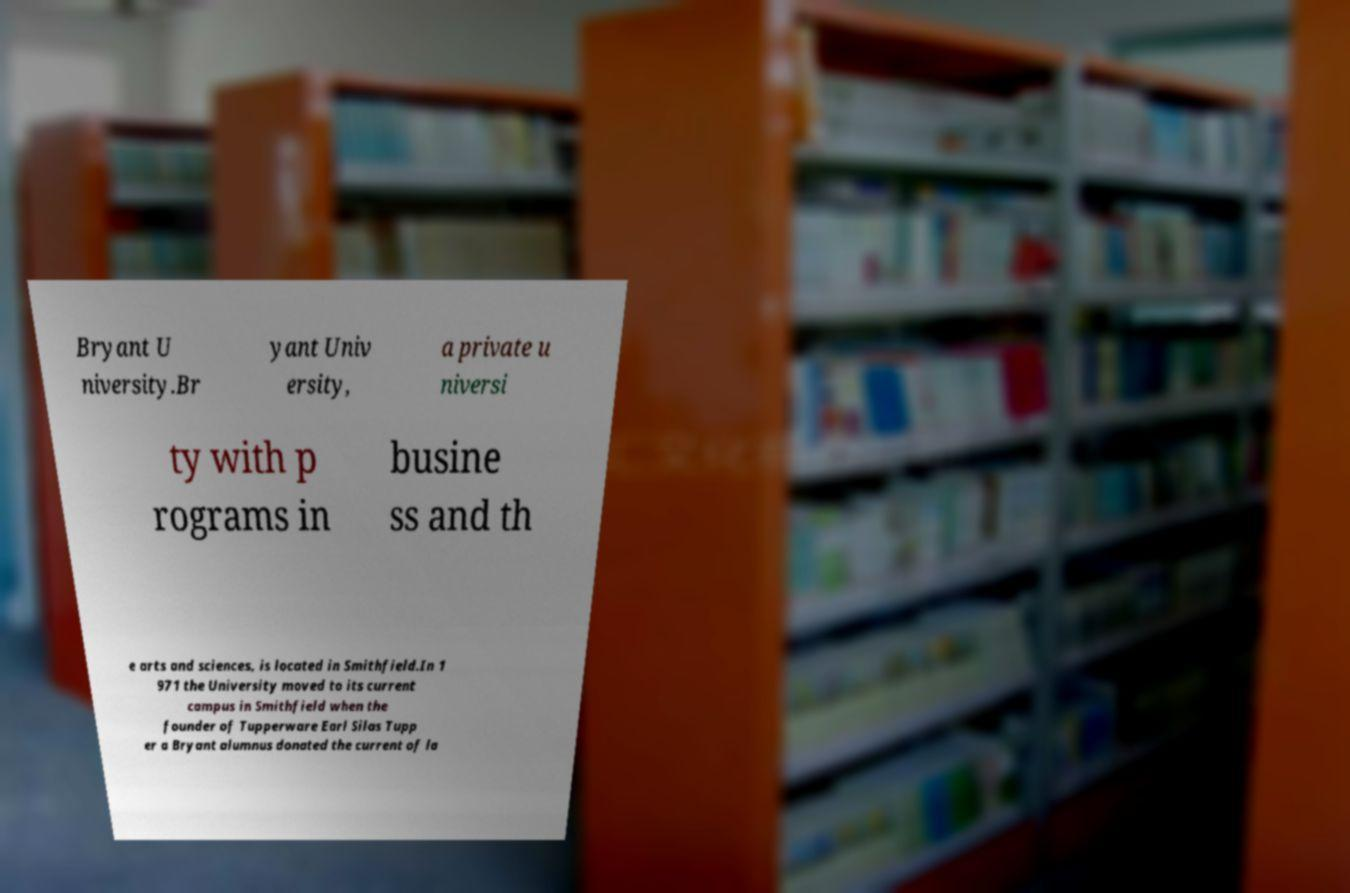Please identify and transcribe the text found in this image. Bryant U niversity.Br yant Univ ersity, a private u niversi ty with p rograms in busine ss and th e arts and sciences, is located in Smithfield.In 1 971 the University moved to its current campus in Smithfield when the founder of Tupperware Earl Silas Tupp er a Bryant alumnus donated the current of la 